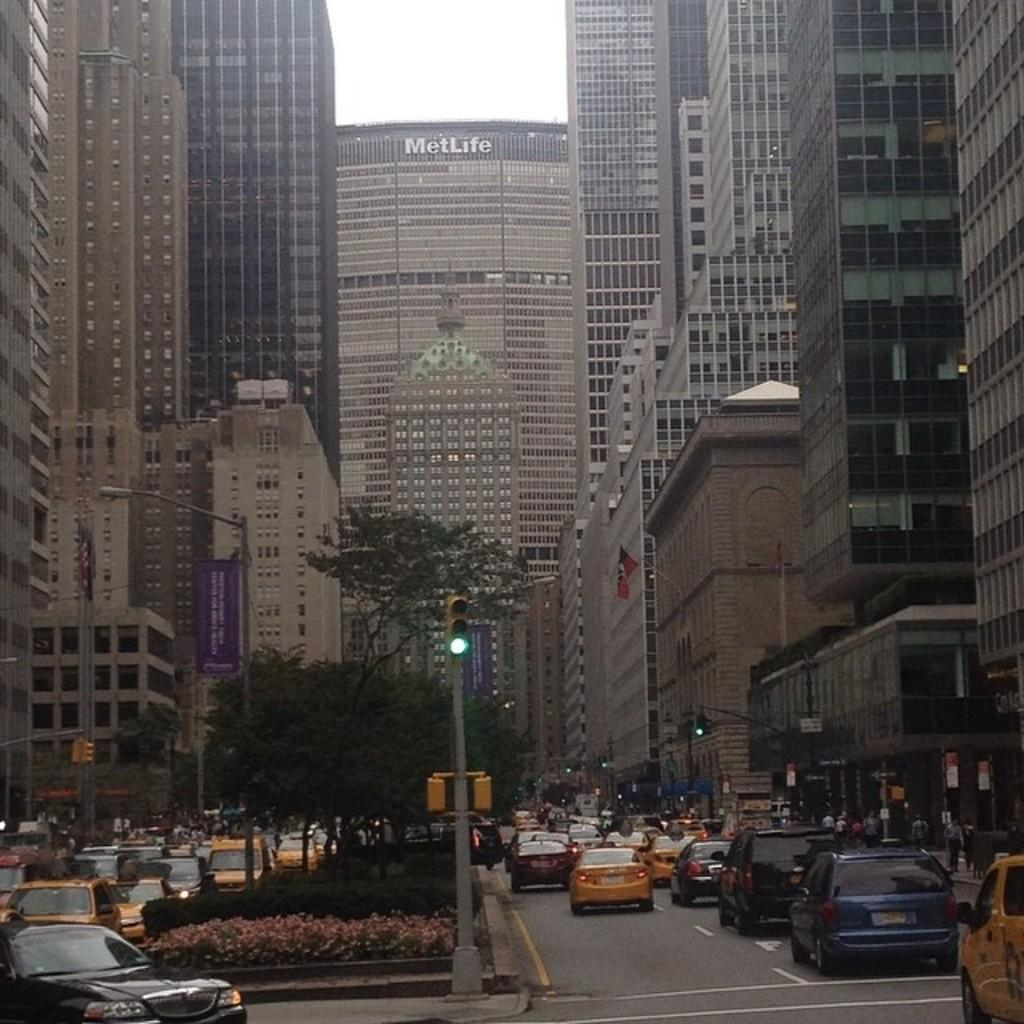What type of vehicles can be seen in the image? There are cars in the image. What natural elements are present in the image? There are trees in the image. What man-made objects can be seen in the image? There are posters and poles in the image. Who or what is present in the image? There are people in the image. What structures can be seen in the background of the image? There are buildings in the background of the image. What part of the natural environment is visible in the image? The sky is visible in the background of the image. How many women are depicted on the posters in the image? There is no information about women on the posters in the image, as the provided facts only mention the presence of posters and not their content. What type of company is represented by the cars in the image? There is no information about the company associated with the cars in the image, as the provided facts only mention the presence of cars and not their brand or affiliation. 